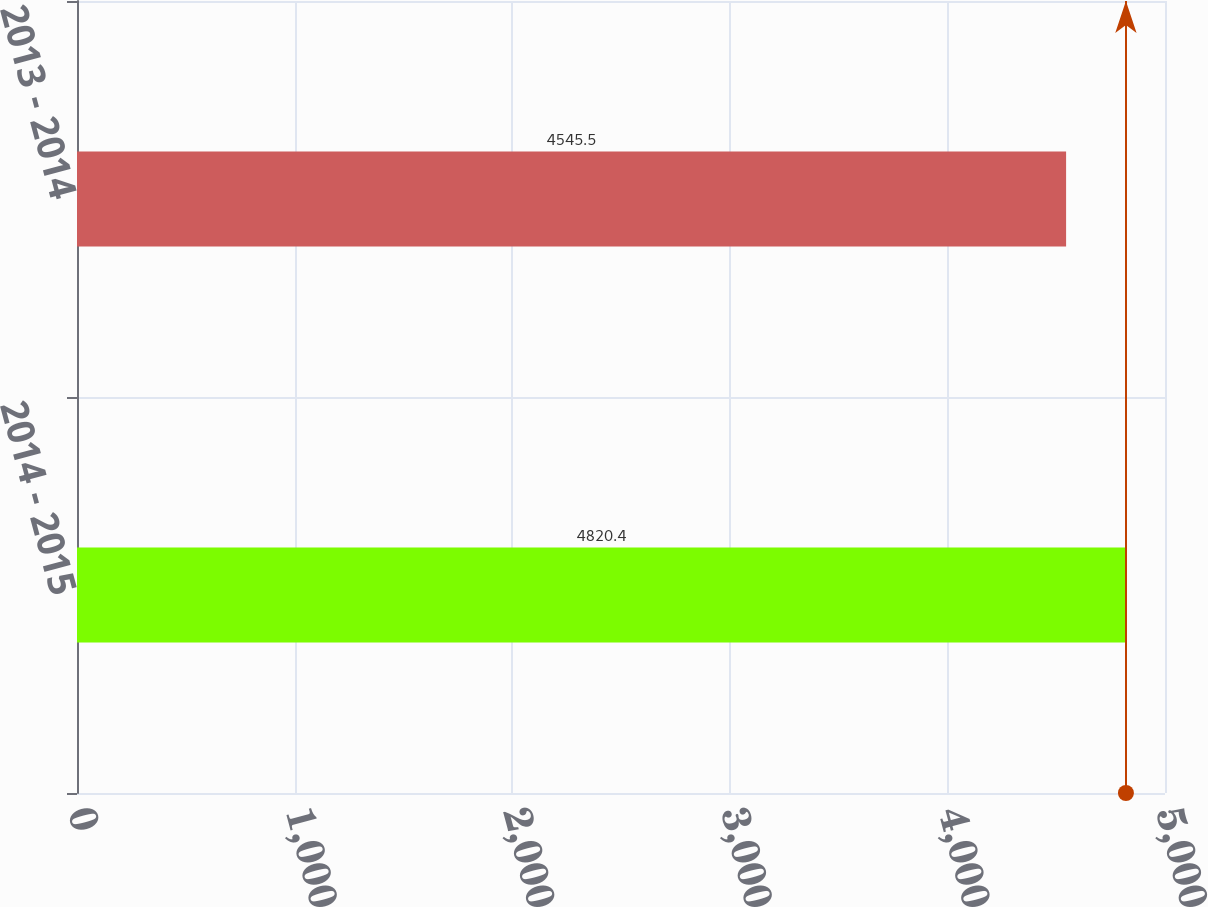Convert chart. <chart><loc_0><loc_0><loc_500><loc_500><bar_chart><fcel>2014 - 2015<fcel>2013 - 2014<nl><fcel>4820.4<fcel>4545.5<nl></chart> 